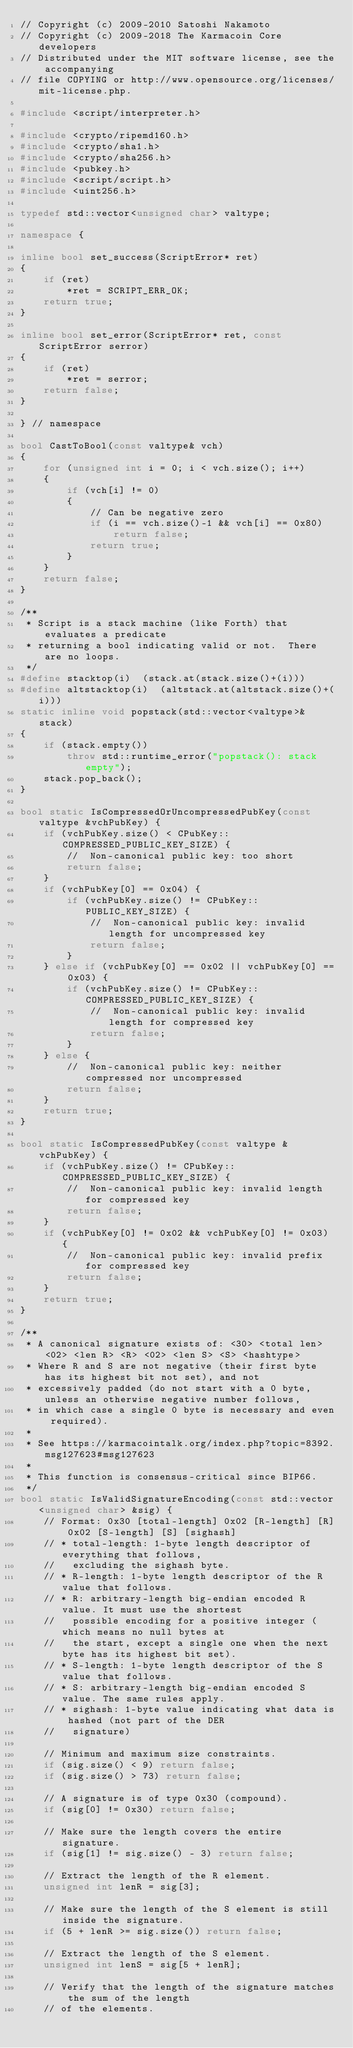Convert code to text. <code><loc_0><loc_0><loc_500><loc_500><_C++_>// Copyright (c) 2009-2010 Satoshi Nakamoto
// Copyright (c) 2009-2018 The Karmacoin Core developers
// Distributed under the MIT software license, see the accompanying
// file COPYING or http://www.opensource.org/licenses/mit-license.php.

#include <script/interpreter.h>

#include <crypto/ripemd160.h>
#include <crypto/sha1.h>
#include <crypto/sha256.h>
#include <pubkey.h>
#include <script/script.h>
#include <uint256.h>

typedef std::vector<unsigned char> valtype;

namespace {

inline bool set_success(ScriptError* ret)
{
    if (ret)
        *ret = SCRIPT_ERR_OK;
    return true;
}

inline bool set_error(ScriptError* ret, const ScriptError serror)
{
    if (ret)
        *ret = serror;
    return false;
}

} // namespace

bool CastToBool(const valtype& vch)
{
    for (unsigned int i = 0; i < vch.size(); i++)
    {
        if (vch[i] != 0)
        {
            // Can be negative zero
            if (i == vch.size()-1 && vch[i] == 0x80)
                return false;
            return true;
        }
    }
    return false;
}

/**
 * Script is a stack machine (like Forth) that evaluates a predicate
 * returning a bool indicating valid or not.  There are no loops.
 */
#define stacktop(i)  (stack.at(stack.size()+(i)))
#define altstacktop(i)  (altstack.at(altstack.size()+(i)))
static inline void popstack(std::vector<valtype>& stack)
{
    if (stack.empty())
        throw std::runtime_error("popstack(): stack empty");
    stack.pop_back();
}

bool static IsCompressedOrUncompressedPubKey(const valtype &vchPubKey) {
    if (vchPubKey.size() < CPubKey::COMPRESSED_PUBLIC_KEY_SIZE) {
        //  Non-canonical public key: too short
        return false;
    }
    if (vchPubKey[0] == 0x04) {
        if (vchPubKey.size() != CPubKey::PUBLIC_KEY_SIZE) {
            //  Non-canonical public key: invalid length for uncompressed key
            return false;
        }
    } else if (vchPubKey[0] == 0x02 || vchPubKey[0] == 0x03) {
        if (vchPubKey.size() != CPubKey::COMPRESSED_PUBLIC_KEY_SIZE) {
            //  Non-canonical public key: invalid length for compressed key
            return false;
        }
    } else {
        //  Non-canonical public key: neither compressed nor uncompressed
        return false;
    }
    return true;
}

bool static IsCompressedPubKey(const valtype &vchPubKey) {
    if (vchPubKey.size() != CPubKey::COMPRESSED_PUBLIC_KEY_SIZE) {
        //  Non-canonical public key: invalid length for compressed key
        return false;
    }
    if (vchPubKey[0] != 0x02 && vchPubKey[0] != 0x03) {
        //  Non-canonical public key: invalid prefix for compressed key
        return false;
    }
    return true;
}

/**
 * A canonical signature exists of: <30> <total len> <02> <len R> <R> <02> <len S> <S> <hashtype>
 * Where R and S are not negative (their first byte has its highest bit not set), and not
 * excessively padded (do not start with a 0 byte, unless an otherwise negative number follows,
 * in which case a single 0 byte is necessary and even required).
 *
 * See https://karmacointalk.org/index.php?topic=8392.msg127623#msg127623
 *
 * This function is consensus-critical since BIP66.
 */
bool static IsValidSignatureEncoding(const std::vector<unsigned char> &sig) {
    // Format: 0x30 [total-length] 0x02 [R-length] [R] 0x02 [S-length] [S] [sighash]
    // * total-length: 1-byte length descriptor of everything that follows,
    //   excluding the sighash byte.
    // * R-length: 1-byte length descriptor of the R value that follows.
    // * R: arbitrary-length big-endian encoded R value. It must use the shortest
    //   possible encoding for a positive integer (which means no null bytes at
    //   the start, except a single one when the next byte has its highest bit set).
    // * S-length: 1-byte length descriptor of the S value that follows.
    // * S: arbitrary-length big-endian encoded S value. The same rules apply.
    // * sighash: 1-byte value indicating what data is hashed (not part of the DER
    //   signature)

    // Minimum and maximum size constraints.
    if (sig.size() < 9) return false;
    if (sig.size() > 73) return false;

    // A signature is of type 0x30 (compound).
    if (sig[0] != 0x30) return false;

    // Make sure the length covers the entire signature.
    if (sig[1] != sig.size() - 3) return false;

    // Extract the length of the R element.
    unsigned int lenR = sig[3];

    // Make sure the length of the S element is still inside the signature.
    if (5 + lenR >= sig.size()) return false;

    // Extract the length of the S element.
    unsigned int lenS = sig[5 + lenR];

    // Verify that the length of the signature matches the sum of the length
    // of the elements.</code> 